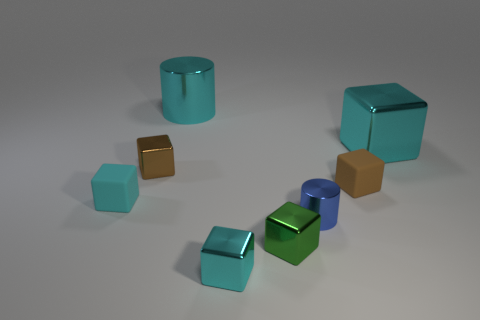There is another cylinder that is made of the same material as the small cylinder; what size is it?
Provide a short and direct response. Large. Do the green shiny thing and the small cyan shiny object have the same shape?
Give a very brief answer. Yes. There is a cylinder that is the same size as the brown metallic object; what is its color?
Your answer should be compact. Blue. There is another brown object that is the same shape as the small brown matte object; what size is it?
Ensure brevity in your answer.  Small. What is the shape of the large cyan shiny object right of the tiny cyan metallic cube?
Provide a short and direct response. Cube. There is a blue shiny thing; is its shape the same as the big cyan thing left of the blue thing?
Your answer should be compact. Yes. Is the number of small cyan matte blocks behind the large cyan metallic cylinder the same as the number of brown rubber objects right of the big cube?
Provide a short and direct response. Yes. There is a matte thing that is the same color as the large block; what is its shape?
Offer a very short reply. Cube. There is a small rubber thing that is in front of the tiny brown matte cube; is it the same color as the small metal cube that is in front of the green metal object?
Provide a succinct answer. Yes. Are there more small brown shiny cubes in front of the small blue object than small cyan matte balls?
Give a very brief answer. No. 